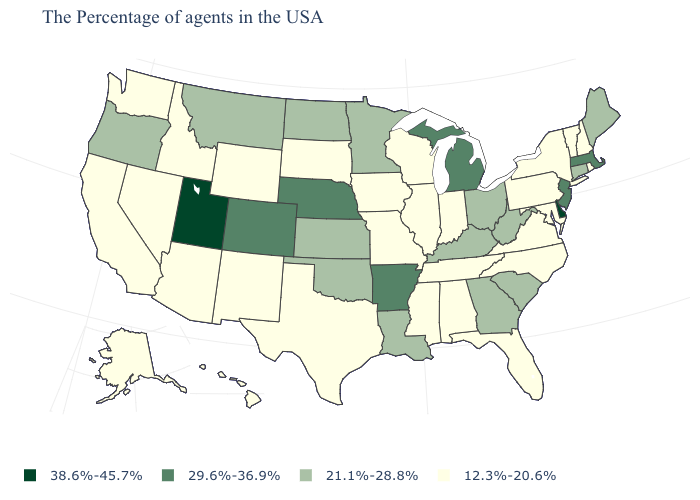Name the states that have a value in the range 21.1%-28.8%?
Keep it brief. Maine, Connecticut, South Carolina, West Virginia, Ohio, Georgia, Kentucky, Louisiana, Minnesota, Kansas, Oklahoma, North Dakota, Montana, Oregon. Does the map have missing data?
Be succinct. No. What is the value of Massachusetts?
Be succinct. 29.6%-36.9%. What is the value of Connecticut?
Write a very short answer. 21.1%-28.8%. Does North Dakota have a lower value than Mississippi?
Answer briefly. No. What is the value of Idaho?
Give a very brief answer. 12.3%-20.6%. What is the value of Pennsylvania?
Answer briefly. 12.3%-20.6%. What is the lowest value in the USA?
Concise answer only. 12.3%-20.6%. Name the states that have a value in the range 29.6%-36.9%?
Be succinct. Massachusetts, New Jersey, Michigan, Arkansas, Nebraska, Colorado. Name the states that have a value in the range 12.3%-20.6%?
Give a very brief answer. Rhode Island, New Hampshire, Vermont, New York, Maryland, Pennsylvania, Virginia, North Carolina, Florida, Indiana, Alabama, Tennessee, Wisconsin, Illinois, Mississippi, Missouri, Iowa, Texas, South Dakota, Wyoming, New Mexico, Arizona, Idaho, Nevada, California, Washington, Alaska, Hawaii. Among the states that border Iowa , does South Dakota have the lowest value?
Give a very brief answer. Yes. Name the states that have a value in the range 29.6%-36.9%?
Write a very short answer. Massachusetts, New Jersey, Michigan, Arkansas, Nebraska, Colorado. What is the highest value in the USA?
Keep it brief. 38.6%-45.7%. Which states hav the highest value in the MidWest?
Keep it brief. Michigan, Nebraska. Is the legend a continuous bar?
Write a very short answer. No. 